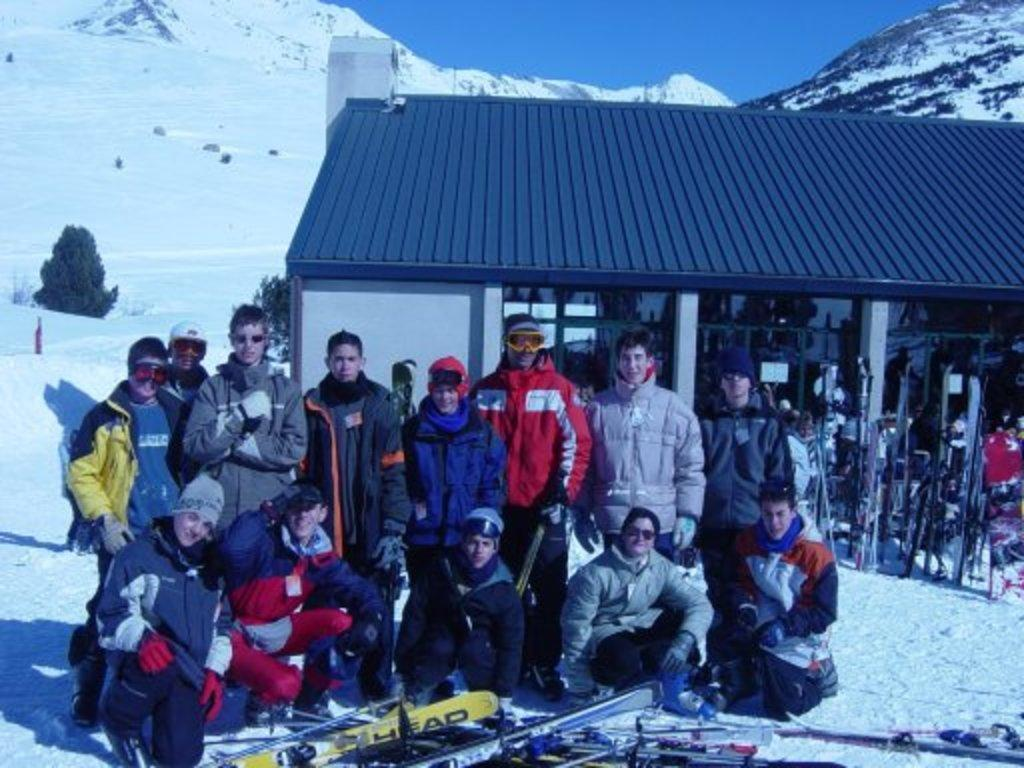How many people are in the image? There is a group of people in the image, but the exact number cannot be determined from the provided facts. What is the weather like in the image? There is snow in the image, which suggests a cold and wintry environment. What type of structure is present in the image? There is a shed in the image. What equipment is visible in the image? Skis are visible in the image. What can be seen in the background of the image? There are trees, mountains, and the sky visible in the background of the image. Where is the kettle located in the image? There is no kettle present in the image. What type of grip does the toothbrush have in the image? There is no toothbrush present in the image. 